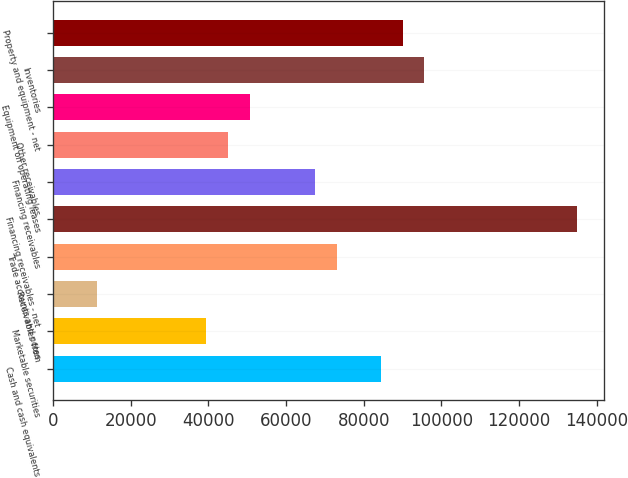Convert chart to OTSL. <chart><loc_0><loc_0><loc_500><loc_500><bar_chart><fcel>Cash and cash equivalents<fcel>Marketable securities<fcel>Receivables from<fcel>Trade accounts and notes<fcel>Financing receivables - net<fcel>Financing receivables<fcel>Other receivables<fcel>Equipment on operating leases<fcel>Inventories<fcel>Property and equipment - net<nl><fcel>84388.8<fcel>39392<fcel>11269.1<fcel>73139.6<fcel>135010<fcel>67515<fcel>45016.6<fcel>50641.2<fcel>95637.9<fcel>90013.3<nl></chart> 